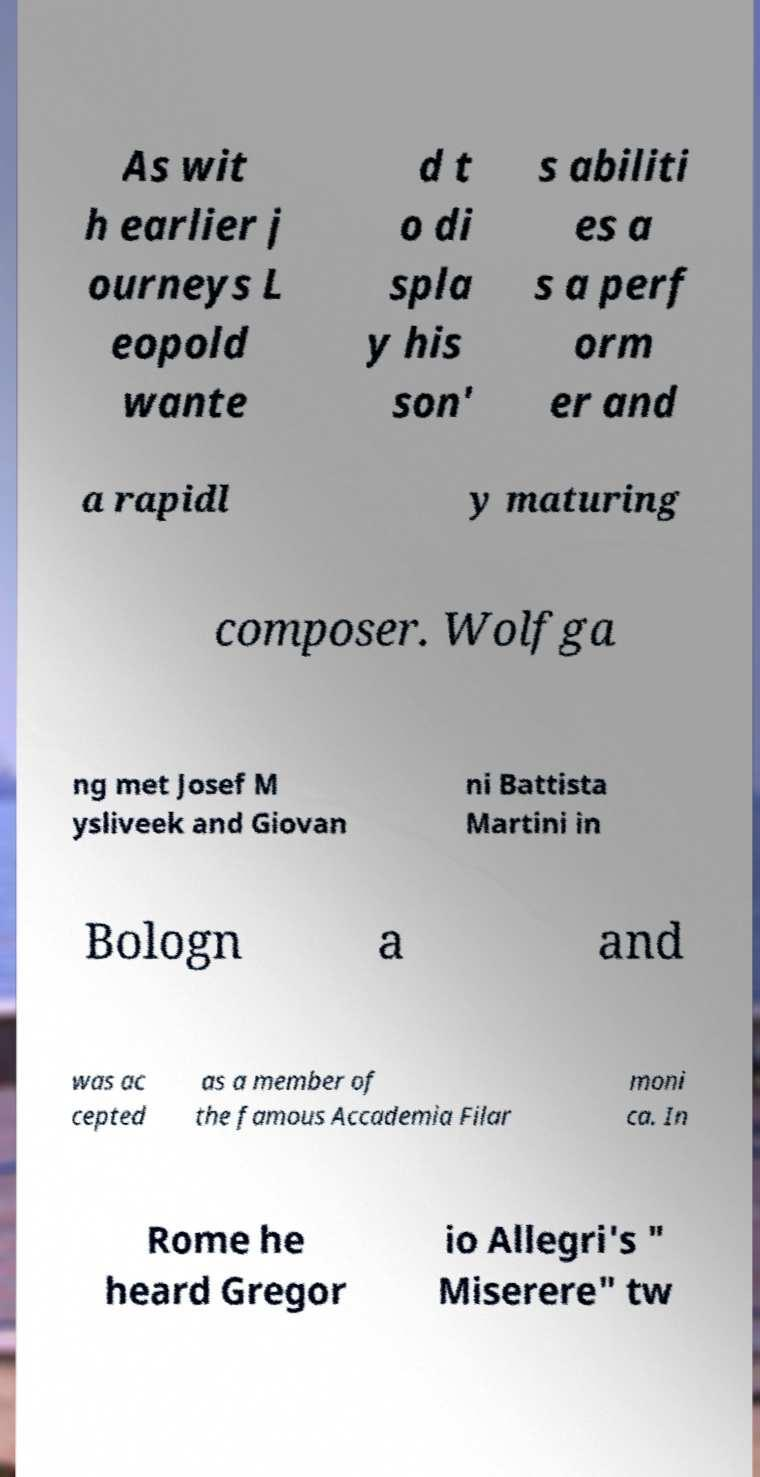Please read and relay the text visible in this image. What does it say? As wit h earlier j ourneys L eopold wante d t o di spla y his son' s abiliti es a s a perf orm er and a rapidl y maturing composer. Wolfga ng met Josef M ysliveek and Giovan ni Battista Martini in Bologn a and was ac cepted as a member of the famous Accademia Filar moni ca. In Rome he heard Gregor io Allegri's " Miserere" tw 